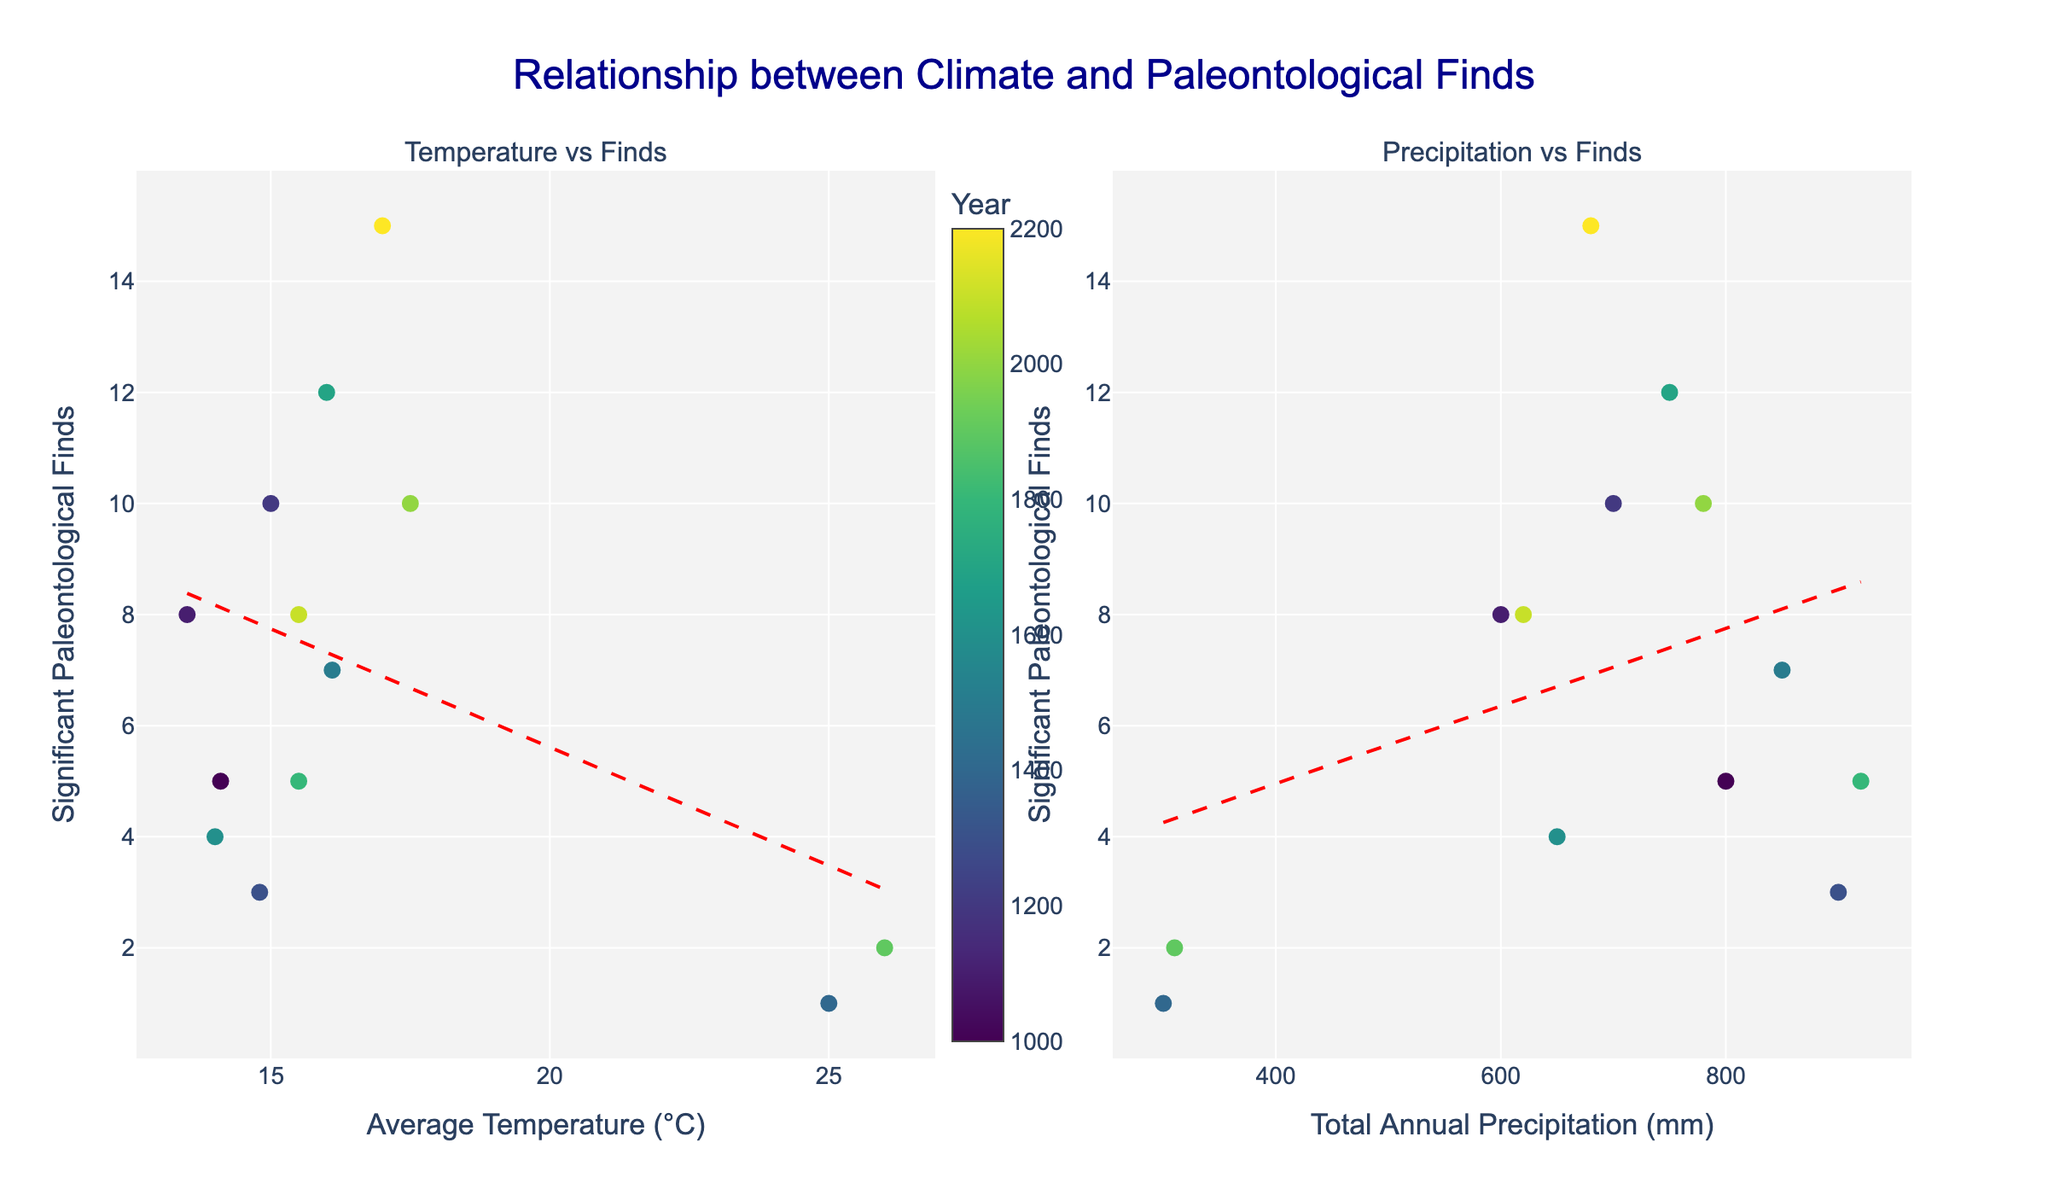What is the title of the figure? The title is located at the top center of the figure. It reads: "Relationship between Climate and Paleontological Finds".
Answer: Relationship between Climate and Paleontological Finds What variables are plotted on the x-axes of the two graphs? The x-axis of the first graph represents "Average Temperature (°C)", while the x-axis of the second graph represents "Total Annual Precipitation (mm)".
Answer: Average Temperature (°C) and Total Annual Precipitation (mm) How many data points are shown in each graph? Both graphs share the same set of data points, which correspond to the provided data for the years and regions. Counting the dots in either graph shows there are 12 data points.
Answer: 12 What region had the highest number of significant paleontological finds and in what year? To find this, look for the highest y-value (significant paleontological finds) in either graph's y-axis. Hovering over the highest point reveals it, which is 15 finds recorded in Asia in the year 2200.
Answer: Asia in 2200 What does the color of the markers represent? The color of the markers represents the specific year, with a color gradient scale visible on the left of the first graph.
Answer: Year In which region and year was the lowest average temperature recorded, and what was the find count? Identify the lowest x-value on the first graph's x-axis (Average Temperature). Hovering over the point reveals that it was Europe in the year 1100 with an average temperature of 13.5°C and 8 significant finds.
Answer: Europe in 1100 with 8 finds What trend is observed between average temperature and significant paleontological finds? A trend line (red dashed line) is added to the first graph to show the relationship. Observing the slope, it shows a positive correlation, indicating that higher temperatures are associated with more significant finds.
Answer: Positive correlation How does the relationship between precipitation and significant paleontological finds compare to the relationship between temperature and finds? Observing the trend line in both graphs, the temperature vs. finds relationship shows a clearer positive trend, while the precipitation vs. finds trend appears less steep and more dispersed.
Answer: Temperature has a clearer positive trend compared to precipitation Considering the years 1400 and 1900, which region had the least number of significant finds, and what were the climate conditions? Locate the points corresponding to the years 1400 and 1900 on the y-axis of either graph. Both of these points are in Africa, showing the least number of significant finds at 1 and 2, with temperatures of 25.0°C and 26.0°C and precipitation of 300 mm and 310 mm, respectively.
Answer: Africa in 1400 and 1900 with temperatures of 25.0°C and 26.0°C and precipitation of 300 mm and 310 mm How did North America's significant finds and climate conditions change between the years 1000 and 2000? Locate the points for North America in the years 1000 and 2000. In 1000, 5 finds were recorded with a temperature of 14.1°C and precipitation of 800 mm. In 2000, 10 finds were recorded with a temperature of 17.5°C and precipitation of 780 mm.
Answer: From 5 to 10 finds; temperature increased from 14.1°C to 17.5°C; precipitation slightly decreased from 800 mm to 780 mm 